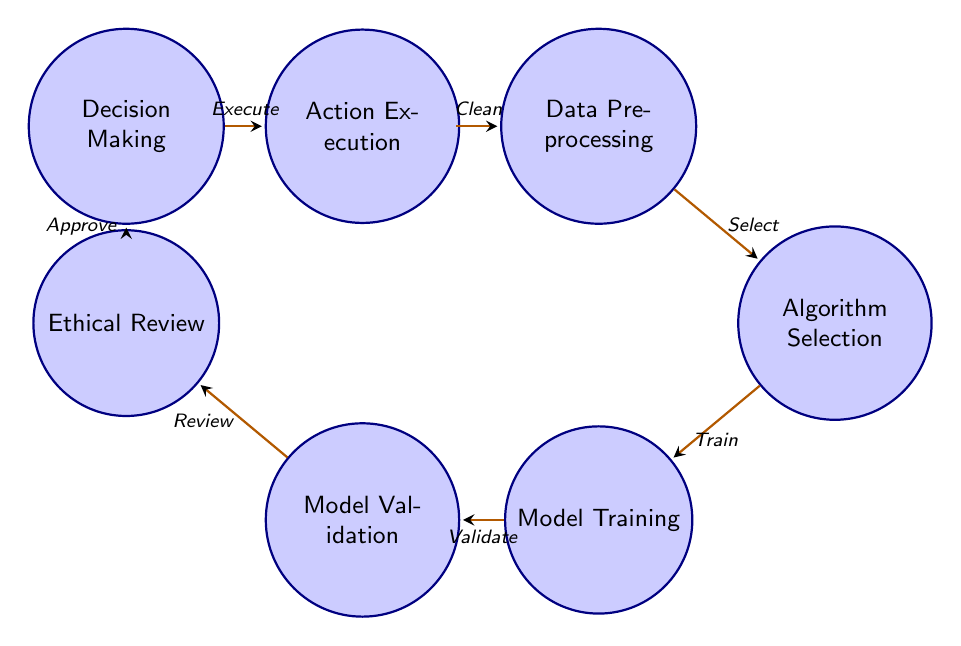What is the first state in the diagram? The diagram starts with the "Data Collection" state, which is positioned at the leftmost part of the diagram.
Answer: Data Collection Which state comes after Data Preprocessing? Following the "Data Preprocessing" state, the next state is "Algorithm Selection," as shown by the directed edge connecting the two.
Answer: Algorithm Selection How many states are in the diagram? Counting all the defined states listed in the diagram, there are a total of eight states.
Answer: Eight What transition follows Model Validation? After "Model Validation," the transition proceeds to "Ethical Review," as indicated by the arrow connecting these two states.
Answer: Ethical Review What action is taken after Decision Making? The action taken after reaching "Decision Making" is "Action Execution," as represented by the transition from "Decision Making" to "Action Execution."
Answer: Action Execution What is the last state in the diagram? The last state in the diagram is "Action Execution," which is positioned at the rightmost side of the diagram.
Answer: Action Execution What are the two states that directly precede Action Execution? The two states preceding "Action Execution" are "Decision Making" and "Ethical Review," as "Decision Making" leads to "Action Execution" directly, and "Ethical Review" comes before "Decision Making."
Answer: Decision Making and Ethical Review Which state involves assessing societal impacts? The state that involves assessing societal impacts is "Ethical Review," which is specifically focused on evaluating whether AI decisions align with ethical standards.
Answer: Ethical Review 